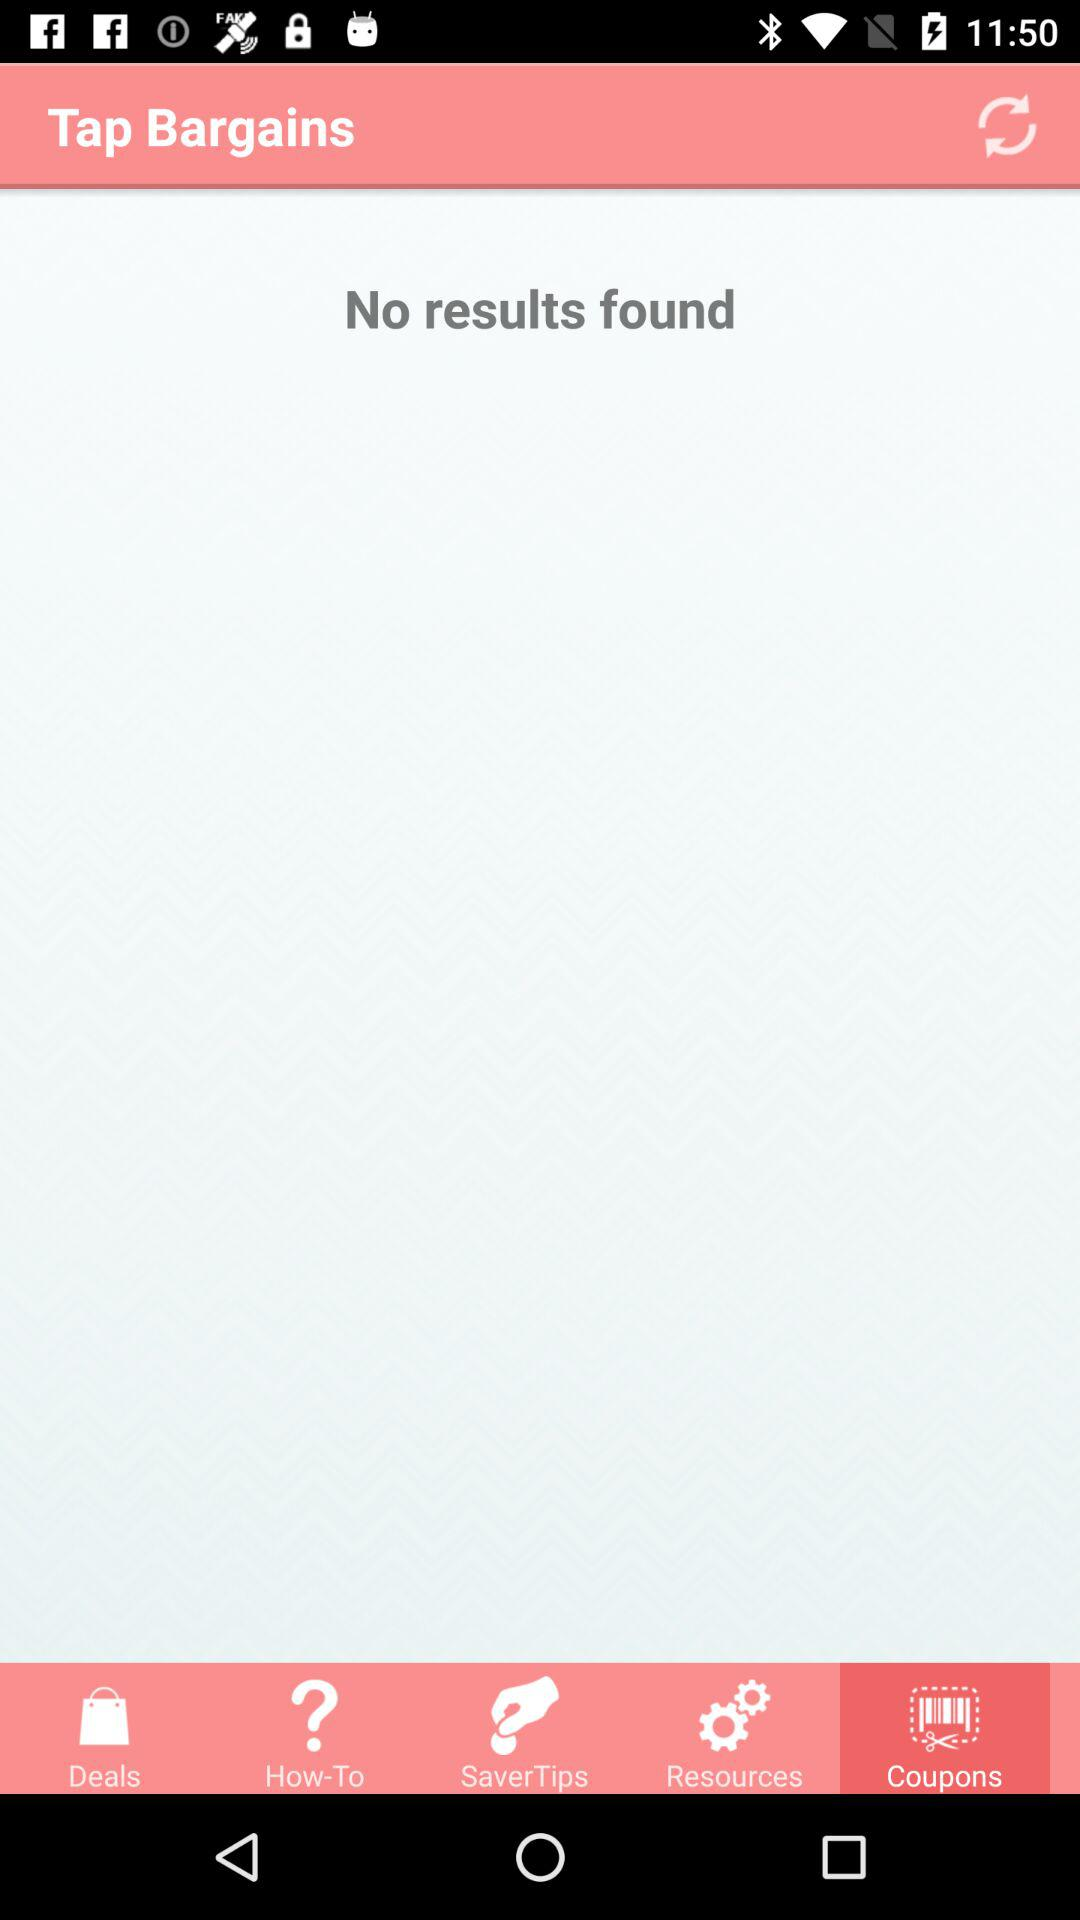Which tab has been selected? The selected tab is "Coupons". 